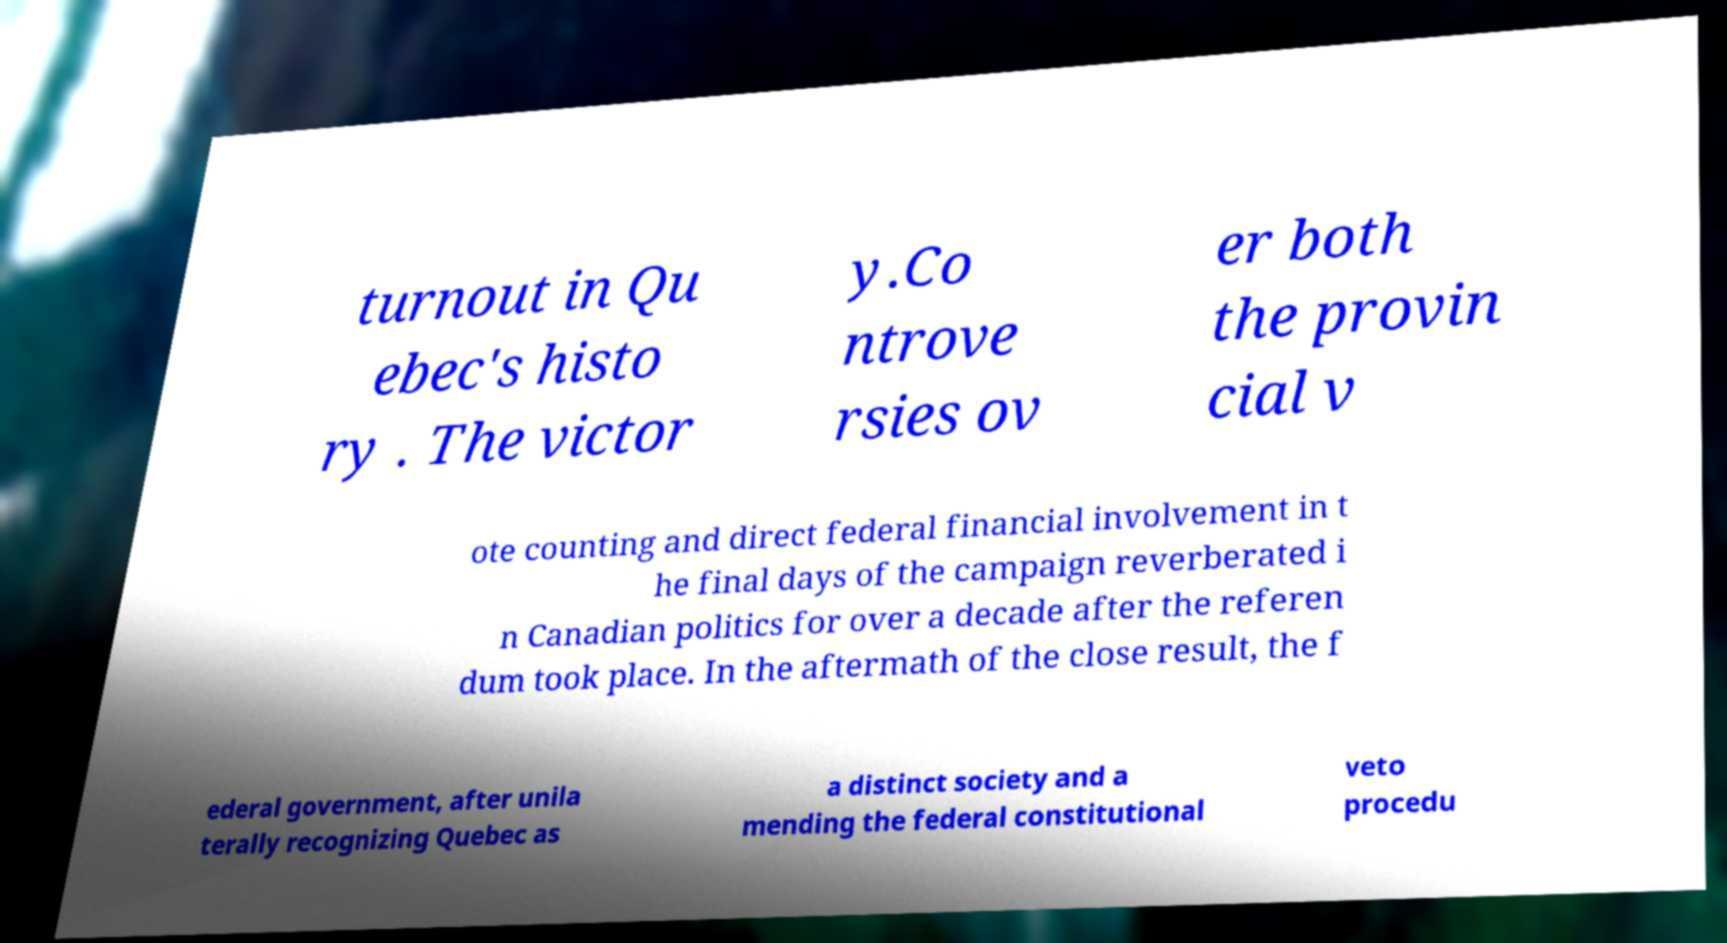Can you accurately transcribe the text from the provided image for me? turnout in Qu ebec's histo ry . The victor y.Co ntrove rsies ov er both the provin cial v ote counting and direct federal financial involvement in t he final days of the campaign reverberated i n Canadian politics for over a decade after the referen dum took place. In the aftermath of the close result, the f ederal government, after unila terally recognizing Quebec as a distinct society and a mending the federal constitutional veto procedu 